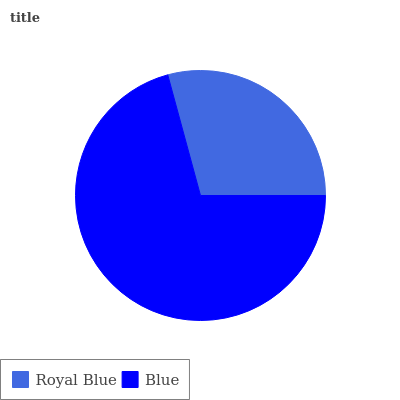Is Royal Blue the minimum?
Answer yes or no. Yes. Is Blue the maximum?
Answer yes or no. Yes. Is Blue the minimum?
Answer yes or no. No. Is Blue greater than Royal Blue?
Answer yes or no. Yes. Is Royal Blue less than Blue?
Answer yes or no. Yes. Is Royal Blue greater than Blue?
Answer yes or no. No. Is Blue less than Royal Blue?
Answer yes or no. No. Is Blue the high median?
Answer yes or no. Yes. Is Royal Blue the low median?
Answer yes or no. Yes. Is Royal Blue the high median?
Answer yes or no. No. Is Blue the low median?
Answer yes or no. No. 